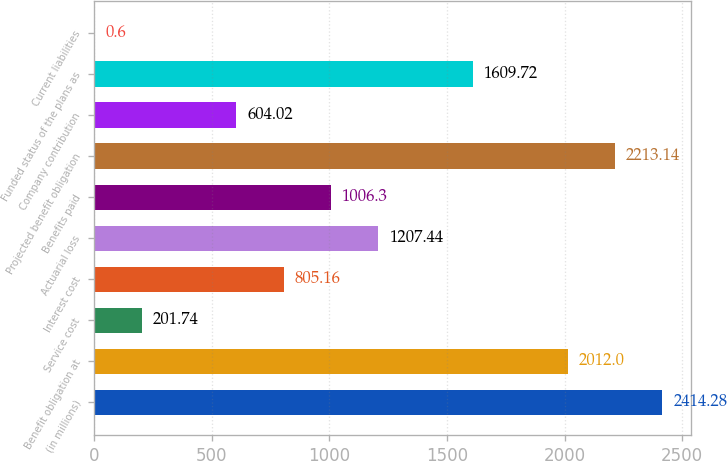Convert chart to OTSL. <chart><loc_0><loc_0><loc_500><loc_500><bar_chart><fcel>(in millions)<fcel>Benefit obligation at<fcel>Service cost<fcel>Interest cost<fcel>Actuarial loss<fcel>Benefits paid<fcel>Projected benefit obligation<fcel>Company contribution<fcel>Funded status of the plans as<fcel>Current liabilities<nl><fcel>2414.28<fcel>2012<fcel>201.74<fcel>805.16<fcel>1207.44<fcel>1006.3<fcel>2213.14<fcel>604.02<fcel>1609.72<fcel>0.6<nl></chart> 